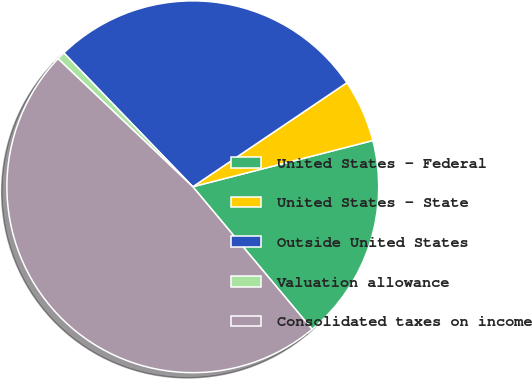Convert chart to OTSL. <chart><loc_0><loc_0><loc_500><loc_500><pie_chart><fcel>United States - Federal<fcel>United States - State<fcel>Outside United States<fcel>Valuation allowance<fcel>Consolidated taxes on income<nl><fcel>17.91%<fcel>5.45%<fcel>27.76%<fcel>0.7%<fcel>48.19%<nl></chart> 